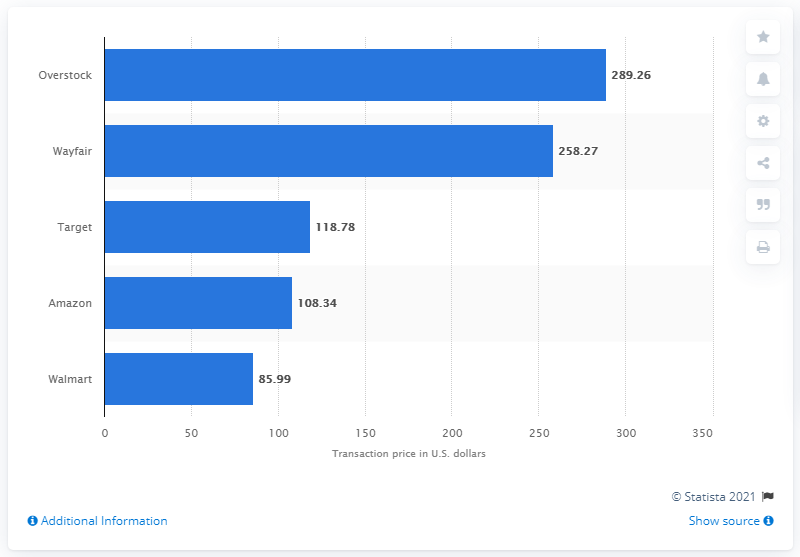Give some essential details in this illustration. In 2018, the average transaction price of Walmart in the United States was 85.99 U.S. dollars. Overstock was the online furniture retailer with the highest average transaction price. 